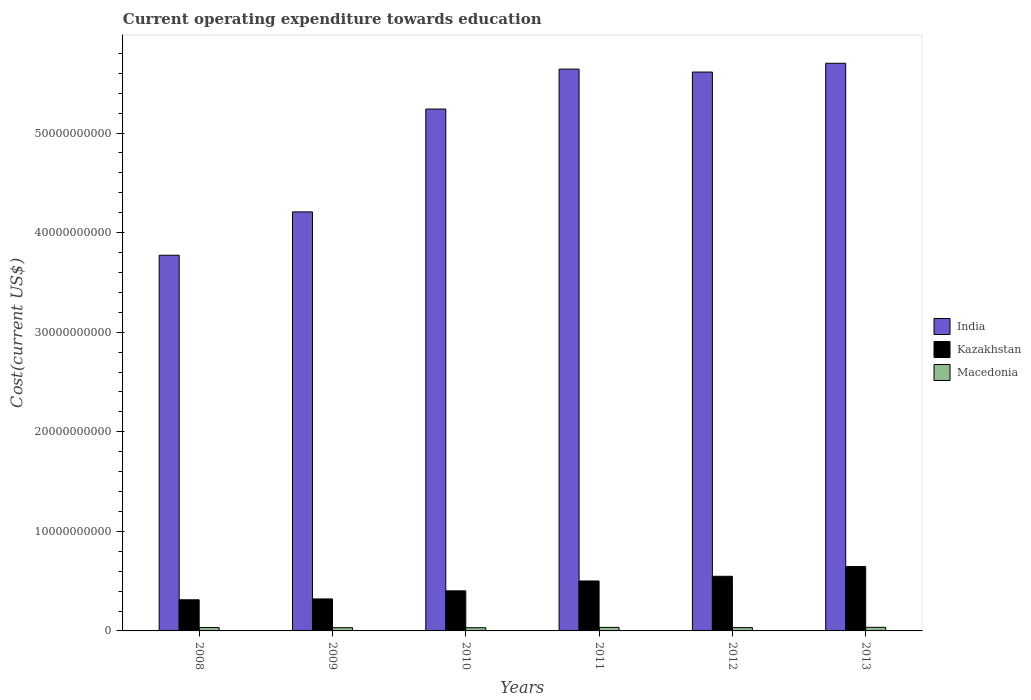Are the number of bars per tick equal to the number of legend labels?
Provide a short and direct response. Yes. How many bars are there on the 4th tick from the left?
Offer a very short reply. 3. How many bars are there on the 2nd tick from the right?
Provide a succinct answer. 3. What is the expenditure towards education in India in 2008?
Your answer should be very brief. 3.77e+1. Across all years, what is the maximum expenditure towards education in India?
Ensure brevity in your answer.  5.70e+1. Across all years, what is the minimum expenditure towards education in India?
Give a very brief answer. 3.77e+1. What is the total expenditure towards education in Kazakhstan in the graph?
Provide a succinct answer. 2.73e+1. What is the difference between the expenditure towards education in India in 2008 and that in 2011?
Your response must be concise. -1.87e+1. What is the difference between the expenditure towards education in India in 2008 and the expenditure towards education in Kazakhstan in 2013?
Your answer should be compact. 3.13e+1. What is the average expenditure towards education in Macedonia per year?
Provide a succinct answer. 3.39e+08. In the year 2011, what is the difference between the expenditure towards education in India and expenditure towards education in Macedonia?
Keep it short and to the point. 5.61e+1. In how many years, is the expenditure towards education in Kazakhstan greater than 44000000000 US$?
Ensure brevity in your answer.  0. What is the ratio of the expenditure towards education in Macedonia in 2012 to that in 2013?
Offer a very short reply. 0.91. What is the difference between the highest and the second highest expenditure towards education in India?
Your response must be concise. 5.89e+08. What is the difference between the highest and the lowest expenditure towards education in Macedonia?
Keep it short and to the point. 4.19e+07. In how many years, is the expenditure towards education in Macedonia greater than the average expenditure towards education in Macedonia taken over all years?
Provide a short and direct response. 2. Is the sum of the expenditure towards education in India in 2010 and 2013 greater than the maximum expenditure towards education in Macedonia across all years?
Your answer should be very brief. Yes. What does the 2nd bar from the left in 2013 represents?
Provide a succinct answer. Kazakhstan. What does the 3rd bar from the right in 2008 represents?
Keep it short and to the point. India. How many bars are there?
Your answer should be very brief. 18. Are all the bars in the graph horizontal?
Provide a succinct answer. No. How many years are there in the graph?
Provide a short and direct response. 6. Are the values on the major ticks of Y-axis written in scientific E-notation?
Offer a very short reply. No. Does the graph contain grids?
Provide a short and direct response. No. Where does the legend appear in the graph?
Ensure brevity in your answer.  Center right. What is the title of the graph?
Make the answer very short. Current operating expenditure towards education. Does "Hungary" appear as one of the legend labels in the graph?
Provide a succinct answer. No. What is the label or title of the X-axis?
Provide a short and direct response. Years. What is the label or title of the Y-axis?
Offer a very short reply. Cost(current US$). What is the Cost(current US$) in India in 2008?
Give a very brief answer. 3.77e+1. What is the Cost(current US$) of Kazakhstan in 2008?
Provide a succinct answer. 3.12e+09. What is the Cost(current US$) of Macedonia in 2008?
Offer a very short reply. 3.39e+08. What is the Cost(current US$) in India in 2009?
Make the answer very short. 4.21e+1. What is the Cost(current US$) in Kazakhstan in 2009?
Give a very brief answer. 3.21e+09. What is the Cost(current US$) of Macedonia in 2009?
Your answer should be compact. 3.23e+08. What is the Cost(current US$) of India in 2010?
Make the answer very short. 5.24e+1. What is the Cost(current US$) of Kazakhstan in 2010?
Your response must be concise. 4.03e+09. What is the Cost(current US$) in Macedonia in 2010?
Offer a very short reply. 3.21e+08. What is the Cost(current US$) in India in 2011?
Keep it short and to the point. 5.64e+1. What is the Cost(current US$) of Kazakhstan in 2011?
Provide a succinct answer. 5.02e+09. What is the Cost(current US$) of Macedonia in 2011?
Your answer should be very brief. 3.57e+08. What is the Cost(current US$) in India in 2012?
Your response must be concise. 5.61e+1. What is the Cost(current US$) in Kazakhstan in 2012?
Your response must be concise. 5.49e+09. What is the Cost(current US$) in Macedonia in 2012?
Give a very brief answer. 3.31e+08. What is the Cost(current US$) in India in 2013?
Offer a terse response. 5.70e+1. What is the Cost(current US$) of Kazakhstan in 2013?
Your answer should be compact. 6.46e+09. What is the Cost(current US$) in Macedonia in 2013?
Offer a very short reply. 3.63e+08. Across all years, what is the maximum Cost(current US$) of India?
Give a very brief answer. 5.70e+1. Across all years, what is the maximum Cost(current US$) in Kazakhstan?
Give a very brief answer. 6.46e+09. Across all years, what is the maximum Cost(current US$) of Macedonia?
Keep it short and to the point. 3.63e+08. Across all years, what is the minimum Cost(current US$) of India?
Provide a short and direct response. 3.77e+1. Across all years, what is the minimum Cost(current US$) of Kazakhstan?
Give a very brief answer. 3.12e+09. Across all years, what is the minimum Cost(current US$) of Macedonia?
Your answer should be compact. 3.21e+08. What is the total Cost(current US$) of India in the graph?
Keep it short and to the point. 3.02e+11. What is the total Cost(current US$) in Kazakhstan in the graph?
Your response must be concise. 2.73e+1. What is the total Cost(current US$) in Macedonia in the graph?
Provide a succinct answer. 2.04e+09. What is the difference between the Cost(current US$) in India in 2008 and that in 2009?
Give a very brief answer. -4.35e+09. What is the difference between the Cost(current US$) in Kazakhstan in 2008 and that in 2009?
Provide a short and direct response. -8.75e+07. What is the difference between the Cost(current US$) in Macedonia in 2008 and that in 2009?
Your response must be concise. 1.58e+07. What is the difference between the Cost(current US$) in India in 2008 and that in 2010?
Make the answer very short. -1.47e+1. What is the difference between the Cost(current US$) in Kazakhstan in 2008 and that in 2010?
Provide a short and direct response. -9.00e+08. What is the difference between the Cost(current US$) in Macedonia in 2008 and that in 2010?
Offer a very short reply. 1.78e+07. What is the difference between the Cost(current US$) of India in 2008 and that in 2011?
Your answer should be very brief. -1.87e+1. What is the difference between the Cost(current US$) in Kazakhstan in 2008 and that in 2011?
Your answer should be very brief. -1.89e+09. What is the difference between the Cost(current US$) in Macedonia in 2008 and that in 2011?
Ensure brevity in your answer.  -1.79e+07. What is the difference between the Cost(current US$) in India in 2008 and that in 2012?
Your response must be concise. -1.84e+1. What is the difference between the Cost(current US$) of Kazakhstan in 2008 and that in 2012?
Your answer should be compact. -2.36e+09. What is the difference between the Cost(current US$) of Macedonia in 2008 and that in 2012?
Make the answer very short. 8.14e+06. What is the difference between the Cost(current US$) of India in 2008 and that in 2013?
Offer a terse response. -1.93e+1. What is the difference between the Cost(current US$) in Kazakhstan in 2008 and that in 2013?
Your response must be concise. -3.34e+09. What is the difference between the Cost(current US$) of Macedonia in 2008 and that in 2013?
Your answer should be very brief. -2.41e+07. What is the difference between the Cost(current US$) in India in 2009 and that in 2010?
Your answer should be very brief. -1.03e+1. What is the difference between the Cost(current US$) of Kazakhstan in 2009 and that in 2010?
Offer a terse response. -8.13e+08. What is the difference between the Cost(current US$) of Macedonia in 2009 and that in 2010?
Make the answer very short. 2.04e+06. What is the difference between the Cost(current US$) in India in 2009 and that in 2011?
Provide a succinct answer. -1.43e+1. What is the difference between the Cost(current US$) in Kazakhstan in 2009 and that in 2011?
Ensure brevity in your answer.  -1.80e+09. What is the difference between the Cost(current US$) of Macedonia in 2009 and that in 2011?
Provide a short and direct response. -3.37e+07. What is the difference between the Cost(current US$) in India in 2009 and that in 2012?
Your answer should be compact. -1.40e+1. What is the difference between the Cost(current US$) in Kazakhstan in 2009 and that in 2012?
Offer a very short reply. -2.27e+09. What is the difference between the Cost(current US$) of Macedonia in 2009 and that in 2012?
Give a very brief answer. -7.62e+06. What is the difference between the Cost(current US$) in India in 2009 and that in 2013?
Keep it short and to the point. -1.49e+1. What is the difference between the Cost(current US$) of Kazakhstan in 2009 and that in 2013?
Ensure brevity in your answer.  -3.25e+09. What is the difference between the Cost(current US$) in Macedonia in 2009 and that in 2013?
Give a very brief answer. -3.99e+07. What is the difference between the Cost(current US$) of India in 2010 and that in 2011?
Your response must be concise. -4.01e+09. What is the difference between the Cost(current US$) in Kazakhstan in 2010 and that in 2011?
Make the answer very short. -9.90e+08. What is the difference between the Cost(current US$) of Macedonia in 2010 and that in 2011?
Ensure brevity in your answer.  -3.57e+07. What is the difference between the Cost(current US$) in India in 2010 and that in 2012?
Your answer should be very brief. -3.72e+09. What is the difference between the Cost(current US$) of Kazakhstan in 2010 and that in 2012?
Give a very brief answer. -1.46e+09. What is the difference between the Cost(current US$) in Macedonia in 2010 and that in 2012?
Make the answer very short. -9.66e+06. What is the difference between the Cost(current US$) of India in 2010 and that in 2013?
Your answer should be compact. -4.60e+09. What is the difference between the Cost(current US$) in Kazakhstan in 2010 and that in 2013?
Provide a short and direct response. -2.44e+09. What is the difference between the Cost(current US$) of Macedonia in 2010 and that in 2013?
Your answer should be compact. -4.19e+07. What is the difference between the Cost(current US$) in India in 2011 and that in 2012?
Offer a terse response. 2.94e+08. What is the difference between the Cost(current US$) in Kazakhstan in 2011 and that in 2012?
Ensure brevity in your answer.  -4.71e+08. What is the difference between the Cost(current US$) in Macedonia in 2011 and that in 2012?
Make the answer very short. 2.61e+07. What is the difference between the Cost(current US$) in India in 2011 and that in 2013?
Give a very brief answer. -5.89e+08. What is the difference between the Cost(current US$) of Kazakhstan in 2011 and that in 2013?
Offer a terse response. -1.45e+09. What is the difference between the Cost(current US$) in Macedonia in 2011 and that in 2013?
Make the answer very short. -6.20e+06. What is the difference between the Cost(current US$) in India in 2012 and that in 2013?
Make the answer very short. -8.83e+08. What is the difference between the Cost(current US$) of Kazakhstan in 2012 and that in 2013?
Provide a succinct answer. -9.76e+08. What is the difference between the Cost(current US$) in Macedonia in 2012 and that in 2013?
Provide a succinct answer. -3.23e+07. What is the difference between the Cost(current US$) in India in 2008 and the Cost(current US$) in Kazakhstan in 2009?
Your response must be concise. 3.45e+1. What is the difference between the Cost(current US$) in India in 2008 and the Cost(current US$) in Macedonia in 2009?
Ensure brevity in your answer.  3.74e+1. What is the difference between the Cost(current US$) in Kazakhstan in 2008 and the Cost(current US$) in Macedonia in 2009?
Offer a terse response. 2.80e+09. What is the difference between the Cost(current US$) in India in 2008 and the Cost(current US$) in Kazakhstan in 2010?
Offer a terse response. 3.37e+1. What is the difference between the Cost(current US$) of India in 2008 and the Cost(current US$) of Macedonia in 2010?
Your response must be concise. 3.74e+1. What is the difference between the Cost(current US$) of Kazakhstan in 2008 and the Cost(current US$) of Macedonia in 2010?
Keep it short and to the point. 2.80e+09. What is the difference between the Cost(current US$) in India in 2008 and the Cost(current US$) in Kazakhstan in 2011?
Your answer should be very brief. 3.27e+1. What is the difference between the Cost(current US$) of India in 2008 and the Cost(current US$) of Macedonia in 2011?
Make the answer very short. 3.74e+1. What is the difference between the Cost(current US$) in Kazakhstan in 2008 and the Cost(current US$) in Macedonia in 2011?
Make the answer very short. 2.77e+09. What is the difference between the Cost(current US$) in India in 2008 and the Cost(current US$) in Kazakhstan in 2012?
Provide a succinct answer. 3.22e+1. What is the difference between the Cost(current US$) of India in 2008 and the Cost(current US$) of Macedonia in 2012?
Offer a terse response. 3.74e+1. What is the difference between the Cost(current US$) in Kazakhstan in 2008 and the Cost(current US$) in Macedonia in 2012?
Ensure brevity in your answer.  2.79e+09. What is the difference between the Cost(current US$) in India in 2008 and the Cost(current US$) in Kazakhstan in 2013?
Provide a succinct answer. 3.13e+1. What is the difference between the Cost(current US$) in India in 2008 and the Cost(current US$) in Macedonia in 2013?
Your answer should be very brief. 3.74e+1. What is the difference between the Cost(current US$) of Kazakhstan in 2008 and the Cost(current US$) of Macedonia in 2013?
Offer a very short reply. 2.76e+09. What is the difference between the Cost(current US$) in India in 2009 and the Cost(current US$) in Kazakhstan in 2010?
Give a very brief answer. 3.81e+1. What is the difference between the Cost(current US$) in India in 2009 and the Cost(current US$) in Macedonia in 2010?
Offer a very short reply. 4.18e+1. What is the difference between the Cost(current US$) of Kazakhstan in 2009 and the Cost(current US$) of Macedonia in 2010?
Give a very brief answer. 2.89e+09. What is the difference between the Cost(current US$) of India in 2009 and the Cost(current US$) of Kazakhstan in 2011?
Offer a terse response. 3.71e+1. What is the difference between the Cost(current US$) in India in 2009 and the Cost(current US$) in Macedonia in 2011?
Offer a very short reply. 4.17e+1. What is the difference between the Cost(current US$) in Kazakhstan in 2009 and the Cost(current US$) in Macedonia in 2011?
Provide a short and direct response. 2.86e+09. What is the difference between the Cost(current US$) of India in 2009 and the Cost(current US$) of Kazakhstan in 2012?
Your response must be concise. 3.66e+1. What is the difference between the Cost(current US$) in India in 2009 and the Cost(current US$) in Macedonia in 2012?
Offer a very short reply. 4.17e+1. What is the difference between the Cost(current US$) in Kazakhstan in 2009 and the Cost(current US$) in Macedonia in 2012?
Give a very brief answer. 2.88e+09. What is the difference between the Cost(current US$) in India in 2009 and the Cost(current US$) in Kazakhstan in 2013?
Ensure brevity in your answer.  3.56e+1. What is the difference between the Cost(current US$) of India in 2009 and the Cost(current US$) of Macedonia in 2013?
Offer a terse response. 4.17e+1. What is the difference between the Cost(current US$) of Kazakhstan in 2009 and the Cost(current US$) of Macedonia in 2013?
Provide a short and direct response. 2.85e+09. What is the difference between the Cost(current US$) in India in 2010 and the Cost(current US$) in Kazakhstan in 2011?
Your response must be concise. 4.74e+1. What is the difference between the Cost(current US$) of India in 2010 and the Cost(current US$) of Macedonia in 2011?
Provide a short and direct response. 5.20e+1. What is the difference between the Cost(current US$) in Kazakhstan in 2010 and the Cost(current US$) in Macedonia in 2011?
Make the answer very short. 3.67e+09. What is the difference between the Cost(current US$) in India in 2010 and the Cost(current US$) in Kazakhstan in 2012?
Offer a terse response. 4.69e+1. What is the difference between the Cost(current US$) in India in 2010 and the Cost(current US$) in Macedonia in 2012?
Your response must be concise. 5.21e+1. What is the difference between the Cost(current US$) of Kazakhstan in 2010 and the Cost(current US$) of Macedonia in 2012?
Your answer should be compact. 3.69e+09. What is the difference between the Cost(current US$) in India in 2010 and the Cost(current US$) in Kazakhstan in 2013?
Your answer should be compact. 4.59e+1. What is the difference between the Cost(current US$) in India in 2010 and the Cost(current US$) in Macedonia in 2013?
Make the answer very short. 5.20e+1. What is the difference between the Cost(current US$) of Kazakhstan in 2010 and the Cost(current US$) of Macedonia in 2013?
Keep it short and to the point. 3.66e+09. What is the difference between the Cost(current US$) of India in 2011 and the Cost(current US$) of Kazakhstan in 2012?
Your response must be concise. 5.09e+1. What is the difference between the Cost(current US$) of India in 2011 and the Cost(current US$) of Macedonia in 2012?
Ensure brevity in your answer.  5.61e+1. What is the difference between the Cost(current US$) of Kazakhstan in 2011 and the Cost(current US$) of Macedonia in 2012?
Provide a short and direct response. 4.68e+09. What is the difference between the Cost(current US$) in India in 2011 and the Cost(current US$) in Kazakhstan in 2013?
Provide a succinct answer. 5.00e+1. What is the difference between the Cost(current US$) of India in 2011 and the Cost(current US$) of Macedonia in 2013?
Ensure brevity in your answer.  5.61e+1. What is the difference between the Cost(current US$) of Kazakhstan in 2011 and the Cost(current US$) of Macedonia in 2013?
Your answer should be compact. 4.65e+09. What is the difference between the Cost(current US$) of India in 2012 and the Cost(current US$) of Kazakhstan in 2013?
Your answer should be very brief. 4.97e+1. What is the difference between the Cost(current US$) of India in 2012 and the Cost(current US$) of Macedonia in 2013?
Make the answer very short. 5.58e+1. What is the difference between the Cost(current US$) in Kazakhstan in 2012 and the Cost(current US$) in Macedonia in 2013?
Provide a succinct answer. 5.12e+09. What is the average Cost(current US$) in India per year?
Give a very brief answer. 5.03e+1. What is the average Cost(current US$) in Kazakhstan per year?
Keep it short and to the point. 4.55e+09. What is the average Cost(current US$) in Macedonia per year?
Keep it short and to the point. 3.39e+08. In the year 2008, what is the difference between the Cost(current US$) of India and Cost(current US$) of Kazakhstan?
Keep it short and to the point. 3.46e+1. In the year 2008, what is the difference between the Cost(current US$) of India and Cost(current US$) of Macedonia?
Provide a succinct answer. 3.74e+1. In the year 2008, what is the difference between the Cost(current US$) of Kazakhstan and Cost(current US$) of Macedonia?
Your answer should be compact. 2.79e+09. In the year 2009, what is the difference between the Cost(current US$) in India and Cost(current US$) in Kazakhstan?
Provide a succinct answer. 3.89e+1. In the year 2009, what is the difference between the Cost(current US$) in India and Cost(current US$) in Macedonia?
Provide a succinct answer. 4.18e+1. In the year 2009, what is the difference between the Cost(current US$) of Kazakhstan and Cost(current US$) of Macedonia?
Provide a short and direct response. 2.89e+09. In the year 2010, what is the difference between the Cost(current US$) in India and Cost(current US$) in Kazakhstan?
Ensure brevity in your answer.  4.84e+1. In the year 2010, what is the difference between the Cost(current US$) in India and Cost(current US$) in Macedonia?
Your answer should be compact. 5.21e+1. In the year 2010, what is the difference between the Cost(current US$) in Kazakhstan and Cost(current US$) in Macedonia?
Give a very brief answer. 3.70e+09. In the year 2011, what is the difference between the Cost(current US$) in India and Cost(current US$) in Kazakhstan?
Give a very brief answer. 5.14e+1. In the year 2011, what is the difference between the Cost(current US$) of India and Cost(current US$) of Macedonia?
Your answer should be compact. 5.61e+1. In the year 2011, what is the difference between the Cost(current US$) of Kazakhstan and Cost(current US$) of Macedonia?
Keep it short and to the point. 4.66e+09. In the year 2012, what is the difference between the Cost(current US$) in India and Cost(current US$) in Kazakhstan?
Offer a terse response. 5.06e+1. In the year 2012, what is the difference between the Cost(current US$) of India and Cost(current US$) of Macedonia?
Ensure brevity in your answer.  5.58e+1. In the year 2012, what is the difference between the Cost(current US$) of Kazakhstan and Cost(current US$) of Macedonia?
Provide a short and direct response. 5.16e+09. In the year 2013, what is the difference between the Cost(current US$) in India and Cost(current US$) in Kazakhstan?
Ensure brevity in your answer.  5.05e+1. In the year 2013, what is the difference between the Cost(current US$) of India and Cost(current US$) of Macedonia?
Provide a succinct answer. 5.66e+1. In the year 2013, what is the difference between the Cost(current US$) of Kazakhstan and Cost(current US$) of Macedonia?
Offer a very short reply. 6.10e+09. What is the ratio of the Cost(current US$) of India in 2008 to that in 2009?
Give a very brief answer. 0.9. What is the ratio of the Cost(current US$) of Kazakhstan in 2008 to that in 2009?
Provide a succinct answer. 0.97. What is the ratio of the Cost(current US$) in Macedonia in 2008 to that in 2009?
Offer a terse response. 1.05. What is the ratio of the Cost(current US$) in India in 2008 to that in 2010?
Provide a succinct answer. 0.72. What is the ratio of the Cost(current US$) of Kazakhstan in 2008 to that in 2010?
Keep it short and to the point. 0.78. What is the ratio of the Cost(current US$) in Macedonia in 2008 to that in 2010?
Give a very brief answer. 1.06. What is the ratio of the Cost(current US$) of India in 2008 to that in 2011?
Your answer should be very brief. 0.67. What is the ratio of the Cost(current US$) of Kazakhstan in 2008 to that in 2011?
Keep it short and to the point. 0.62. What is the ratio of the Cost(current US$) of Macedonia in 2008 to that in 2011?
Provide a succinct answer. 0.95. What is the ratio of the Cost(current US$) in India in 2008 to that in 2012?
Your answer should be very brief. 0.67. What is the ratio of the Cost(current US$) of Kazakhstan in 2008 to that in 2012?
Provide a succinct answer. 0.57. What is the ratio of the Cost(current US$) of Macedonia in 2008 to that in 2012?
Make the answer very short. 1.02. What is the ratio of the Cost(current US$) in India in 2008 to that in 2013?
Keep it short and to the point. 0.66. What is the ratio of the Cost(current US$) in Kazakhstan in 2008 to that in 2013?
Your response must be concise. 0.48. What is the ratio of the Cost(current US$) in Macedonia in 2008 to that in 2013?
Provide a short and direct response. 0.93. What is the ratio of the Cost(current US$) of India in 2009 to that in 2010?
Keep it short and to the point. 0.8. What is the ratio of the Cost(current US$) of Kazakhstan in 2009 to that in 2010?
Your answer should be compact. 0.8. What is the ratio of the Cost(current US$) of Macedonia in 2009 to that in 2010?
Your response must be concise. 1.01. What is the ratio of the Cost(current US$) of India in 2009 to that in 2011?
Offer a very short reply. 0.75. What is the ratio of the Cost(current US$) of Kazakhstan in 2009 to that in 2011?
Offer a very short reply. 0.64. What is the ratio of the Cost(current US$) of Macedonia in 2009 to that in 2011?
Give a very brief answer. 0.91. What is the ratio of the Cost(current US$) in India in 2009 to that in 2012?
Provide a succinct answer. 0.75. What is the ratio of the Cost(current US$) of Kazakhstan in 2009 to that in 2012?
Provide a succinct answer. 0.59. What is the ratio of the Cost(current US$) of India in 2009 to that in 2013?
Ensure brevity in your answer.  0.74. What is the ratio of the Cost(current US$) in Kazakhstan in 2009 to that in 2013?
Provide a short and direct response. 0.5. What is the ratio of the Cost(current US$) of Macedonia in 2009 to that in 2013?
Provide a succinct answer. 0.89. What is the ratio of the Cost(current US$) of India in 2010 to that in 2011?
Ensure brevity in your answer.  0.93. What is the ratio of the Cost(current US$) of Kazakhstan in 2010 to that in 2011?
Offer a terse response. 0.8. What is the ratio of the Cost(current US$) of Macedonia in 2010 to that in 2011?
Your answer should be very brief. 0.9. What is the ratio of the Cost(current US$) in India in 2010 to that in 2012?
Provide a short and direct response. 0.93. What is the ratio of the Cost(current US$) of Kazakhstan in 2010 to that in 2012?
Ensure brevity in your answer.  0.73. What is the ratio of the Cost(current US$) of Macedonia in 2010 to that in 2012?
Keep it short and to the point. 0.97. What is the ratio of the Cost(current US$) of India in 2010 to that in 2013?
Offer a very short reply. 0.92. What is the ratio of the Cost(current US$) in Kazakhstan in 2010 to that in 2013?
Provide a succinct answer. 0.62. What is the ratio of the Cost(current US$) in Macedonia in 2010 to that in 2013?
Offer a very short reply. 0.88. What is the ratio of the Cost(current US$) in India in 2011 to that in 2012?
Provide a short and direct response. 1.01. What is the ratio of the Cost(current US$) in Kazakhstan in 2011 to that in 2012?
Keep it short and to the point. 0.91. What is the ratio of the Cost(current US$) in Macedonia in 2011 to that in 2012?
Give a very brief answer. 1.08. What is the ratio of the Cost(current US$) of Kazakhstan in 2011 to that in 2013?
Offer a very short reply. 0.78. What is the ratio of the Cost(current US$) in Macedonia in 2011 to that in 2013?
Your answer should be compact. 0.98. What is the ratio of the Cost(current US$) in India in 2012 to that in 2013?
Offer a very short reply. 0.98. What is the ratio of the Cost(current US$) in Kazakhstan in 2012 to that in 2013?
Make the answer very short. 0.85. What is the ratio of the Cost(current US$) of Macedonia in 2012 to that in 2013?
Provide a short and direct response. 0.91. What is the difference between the highest and the second highest Cost(current US$) in India?
Make the answer very short. 5.89e+08. What is the difference between the highest and the second highest Cost(current US$) in Kazakhstan?
Give a very brief answer. 9.76e+08. What is the difference between the highest and the second highest Cost(current US$) in Macedonia?
Your answer should be very brief. 6.20e+06. What is the difference between the highest and the lowest Cost(current US$) in India?
Your answer should be very brief. 1.93e+1. What is the difference between the highest and the lowest Cost(current US$) in Kazakhstan?
Keep it short and to the point. 3.34e+09. What is the difference between the highest and the lowest Cost(current US$) of Macedonia?
Ensure brevity in your answer.  4.19e+07. 